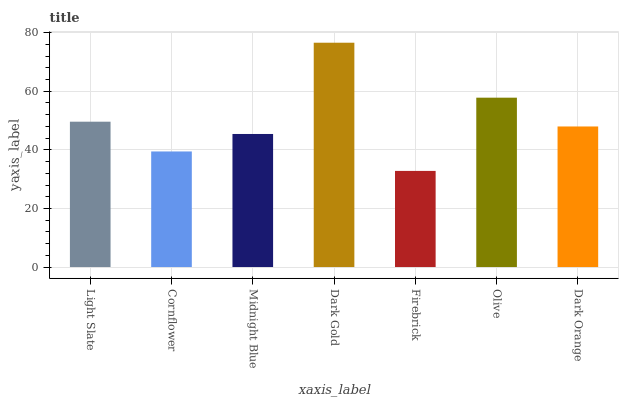Is Firebrick the minimum?
Answer yes or no. Yes. Is Dark Gold the maximum?
Answer yes or no. Yes. Is Cornflower the minimum?
Answer yes or no. No. Is Cornflower the maximum?
Answer yes or no. No. Is Light Slate greater than Cornflower?
Answer yes or no. Yes. Is Cornflower less than Light Slate?
Answer yes or no. Yes. Is Cornflower greater than Light Slate?
Answer yes or no. No. Is Light Slate less than Cornflower?
Answer yes or no. No. Is Dark Orange the high median?
Answer yes or no. Yes. Is Dark Orange the low median?
Answer yes or no. Yes. Is Firebrick the high median?
Answer yes or no. No. Is Firebrick the low median?
Answer yes or no. No. 